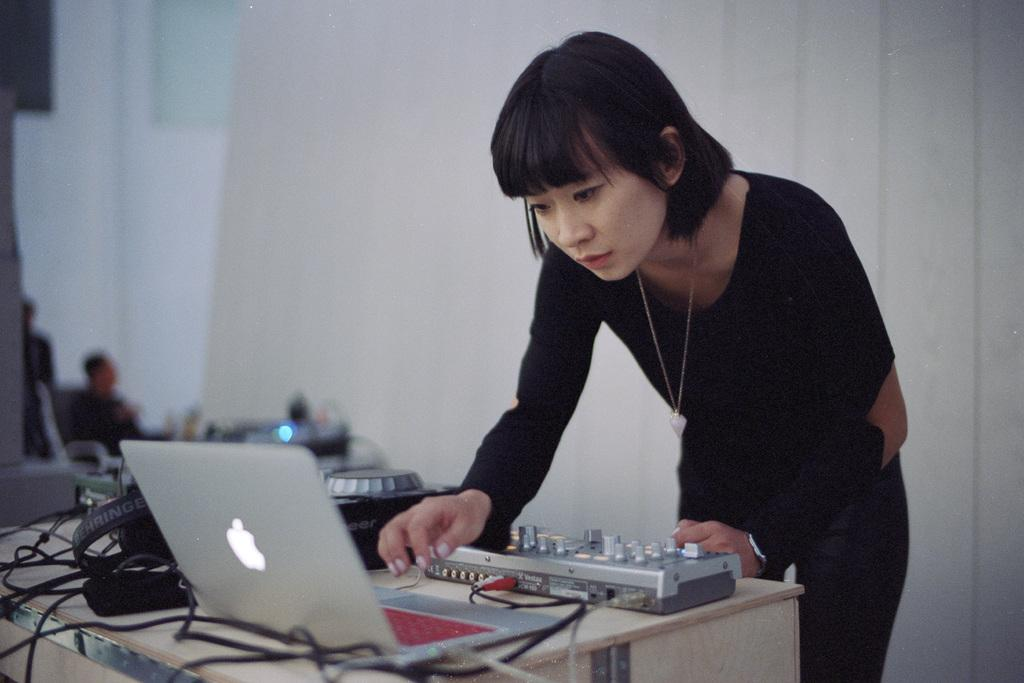Who is the main subject in the image? There is a woman in the image. What is the woman interacting with in the image? There is a laptop in front of the woman. What is on the platform in front of the woman? There are objects on a platform in front of the woman. Can you describe the background of the image? There is a tall person and objects visible in the background of the image. What type of payment is the woman making in the image? There is no indication of any payment being made in the image. The woman is simply interacting with a laptop and there are objects on a platform in front of her. 